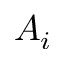Convert formula to latex. <formula><loc_0><loc_0><loc_500><loc_500>A _ { i }</formula> 